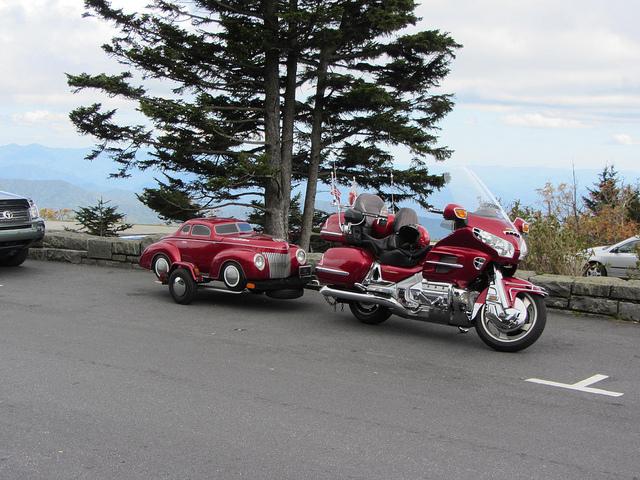What is bigger, the bike or the car?
Answer briefly. Bike. What is attached to the motorcycle?
Give a very brief answer. Car. How many cars are in the picture?
Concise answer only. 3. Are there clouds in the sky?
Concise answer only. Yes. 